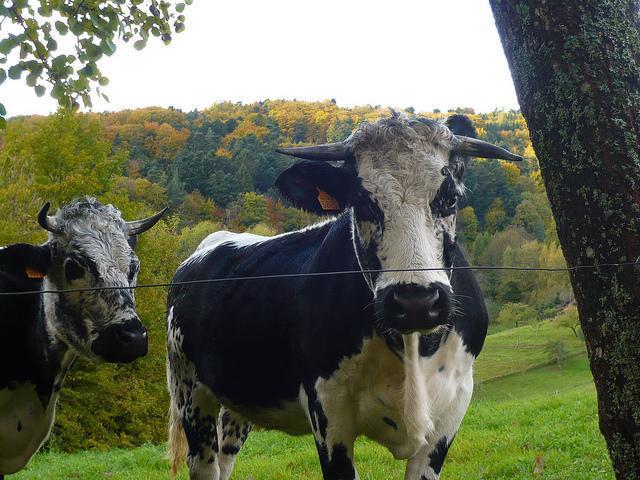How many cows can you see?
Give a very brief answer. 2. 